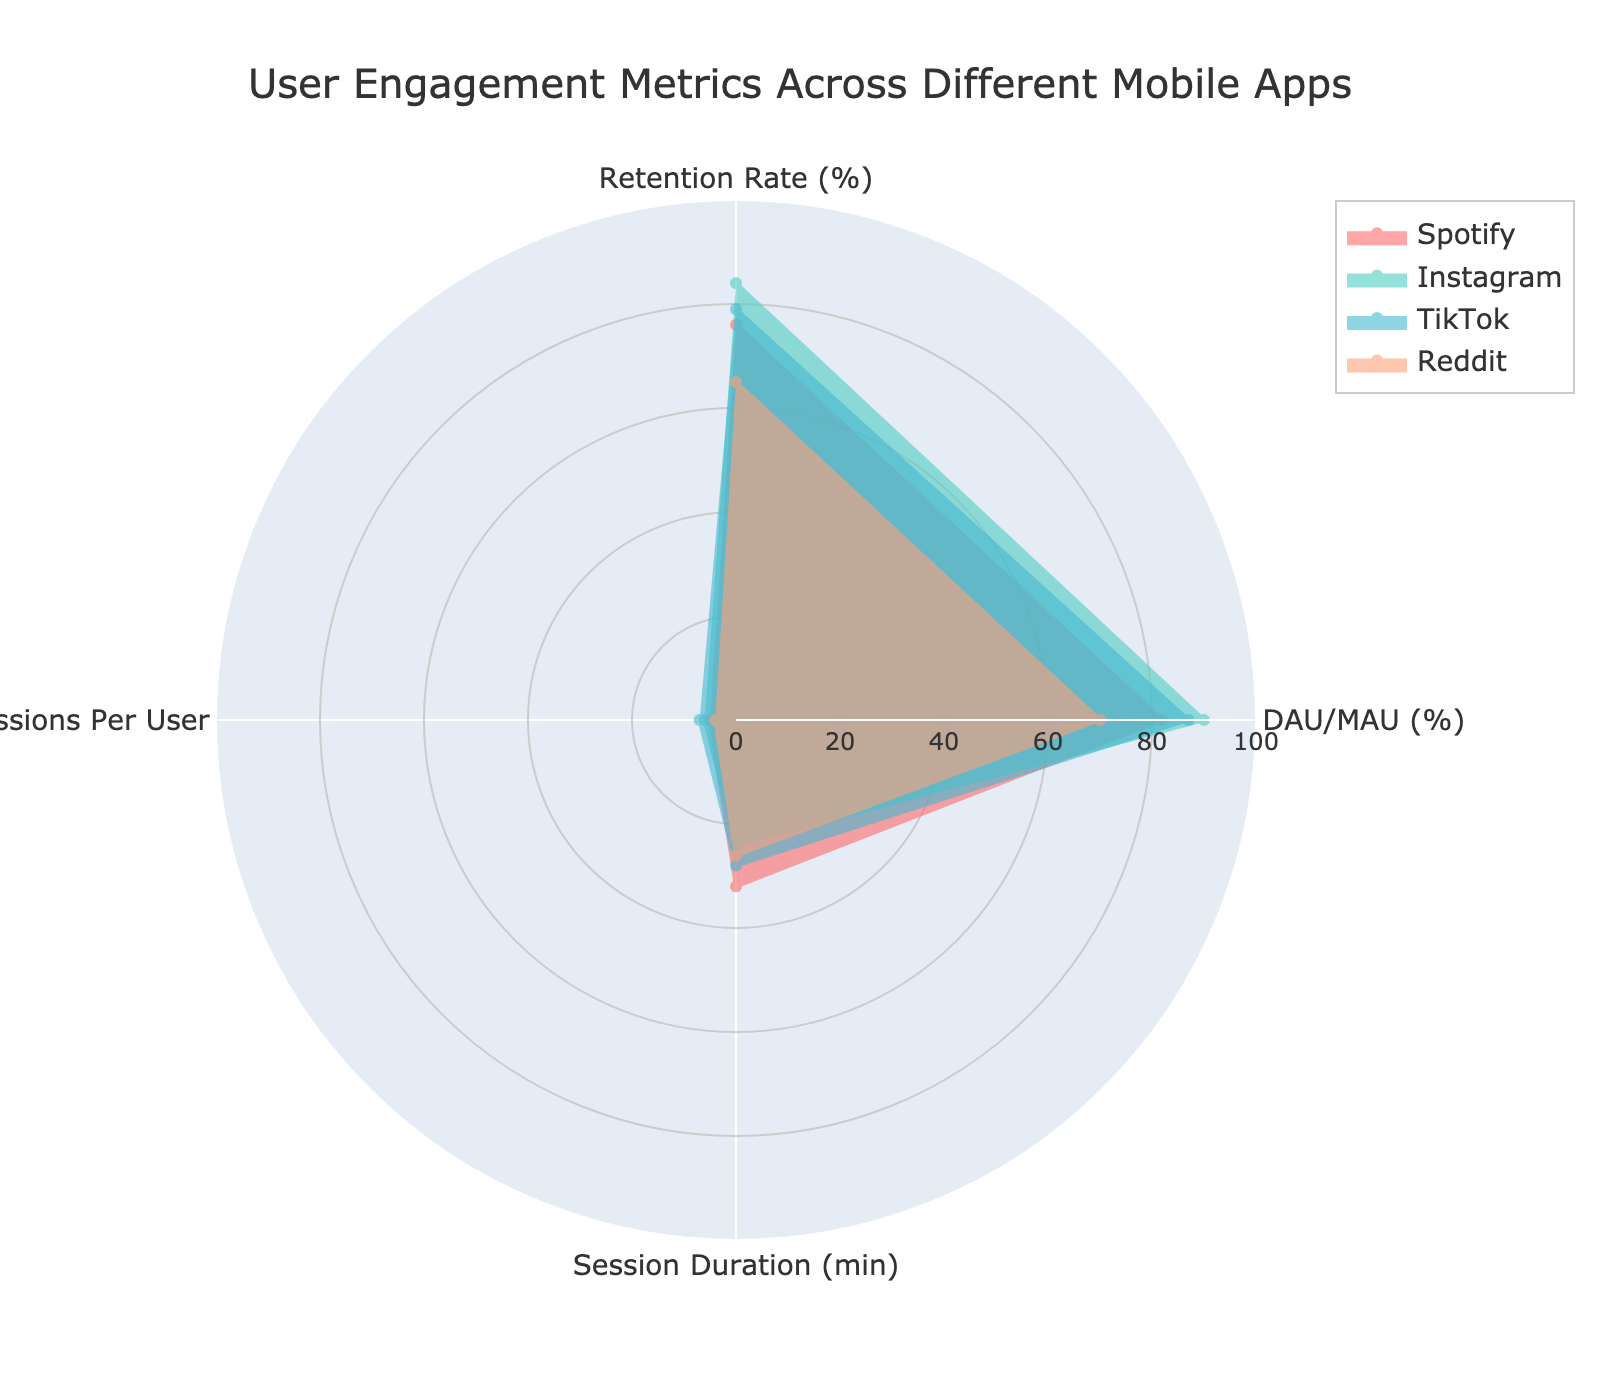Which app has the highest retention rate? From the radar chart, the retention rate is clearly marked on one of the axes. By comparing all apps' retention rates, Instagram has the highest value.
Answer: Instagram Which app has the lowest session duration? The session duration can be observed on one of the axes. By comparing all apps' values in this metric, Spotify has the highest session duration.
Answer: Spotify What is the difference in retention rate between Instagram and Reddit? Look at the retention rate values for both Instagram and Reddit on the radar chart. Instagram has a retention rate of 84%, and Reddit has 65%. The difference is 84 - 65 = 19.
Answer: 19 How does TikTok compare to Spotify in terms of Average Sessions Per User? Locate the Average Sessions Per User axis and compare the values for TikTok and Spotify. TikTok shows 7 sessions per user, while Spotify shows 5. TikTok has more average sessions per user than Spotify.
Answer: TikTok has more Which app has the highest DAU/MAU percentage? The DAU/MAU percentage is located on one of the axes in the radar chart. The app with the highest value in this metric is Instagram at 90%.
Answer: Instagram What is the average session duration across all apps? The session durations for all apps are Spotify (32), Instagram (24), TikTok (28), and Reddit (26). Adding those together and dividing by the number of apps gives (32 + 24 + 28 + 26)/4 = 27.5 minutes.
Answer: 27.5 Is there an app that scores the highest in multiple metrics? Examine the radar chart and identify any app that has the highest value in more than one metric. Instagram scores the highest in both the retention rate and DAU/MAU percentage.
Answer: Yes, Instagram Compare the user engagement metrics between Reddit and TikTok. By looking at the radar chart, you can see that TikTok generally has higher values in all metrics compared to Reddit except for the session duration. Specifically, TikTok has higher retention rate, DAU/MAU, and average sessions per user, while Reddit has a session duration of 26 minutes compared to TikTok's 28 minutes.
Answer: TikTok generally higher except session duration Which two apps have the closest DAU/MAU percentages? Review the values for the DAU/MAU percentages on the radar chart. TikTok has 87%, Spotify has 82%. The smallest difference is between TikTok and Spotify, a difference of 87 - 82 = 5%.
Answer: TikTok and Spotify 